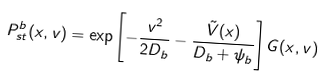<formula> <loc_0><loc_0><loc_500><loc_500>P _ { s t } ^ { b } ( x , v ) = \exp \left [ - \frac { v ^ { 2 } } { 2 D _ { b } } - \frac { \tilde { V } ( x ) } { D _ { b } + \psi _ { b } } \right ] G ( x , v )</formula> 